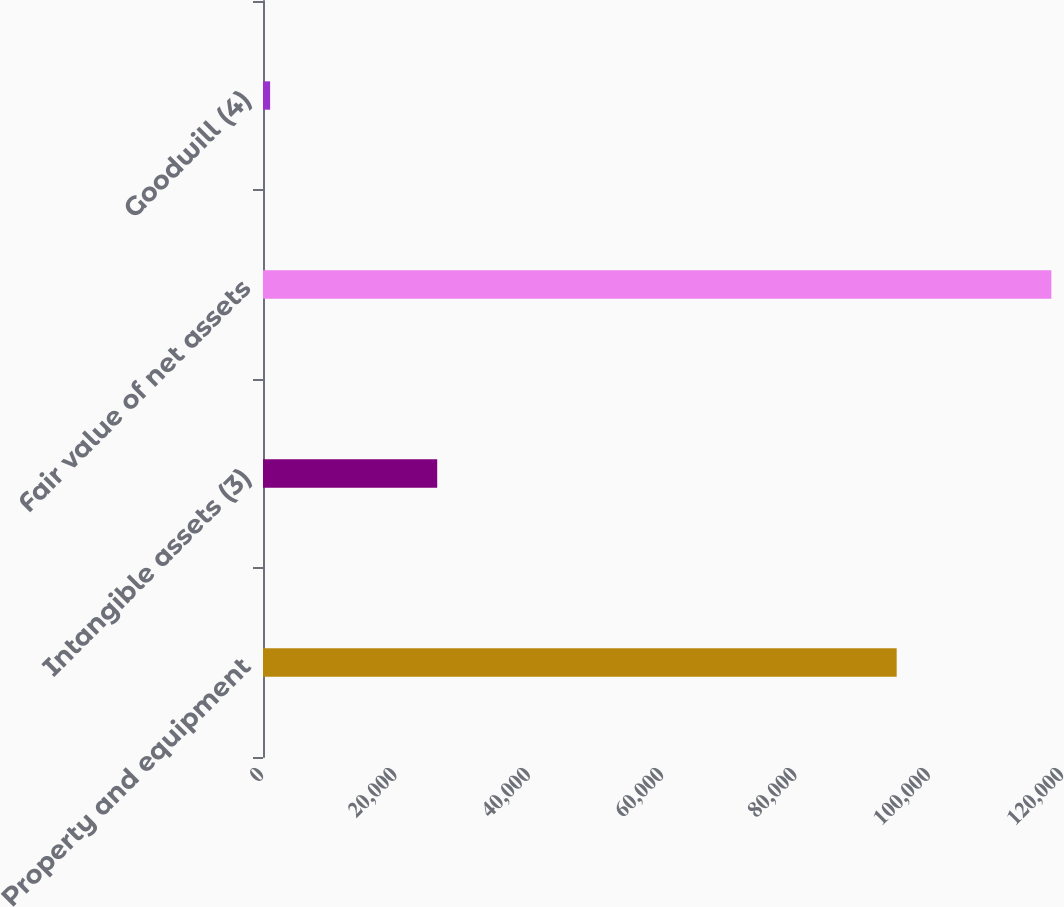<chart> <loc_0><loc_0><loc_500><loc_500><bar_chart><fcel>Property and equipment<fcel>Intangible assets (3)<fcel>Fair value of net assets<fcel>Goodwill (4)<nl><fcel>95052<fcel>26132<fcel>118255<fcel>1067<nl></chart> 